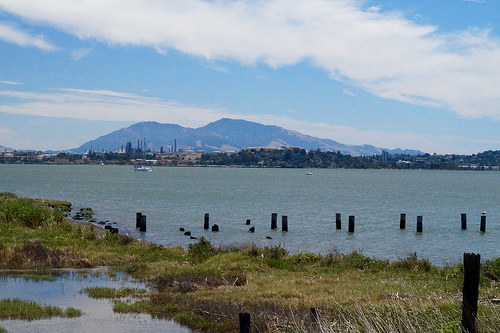<image>
Is the post in the water? Yes. The post is contained within or inside the water, showing a containment relationship. 